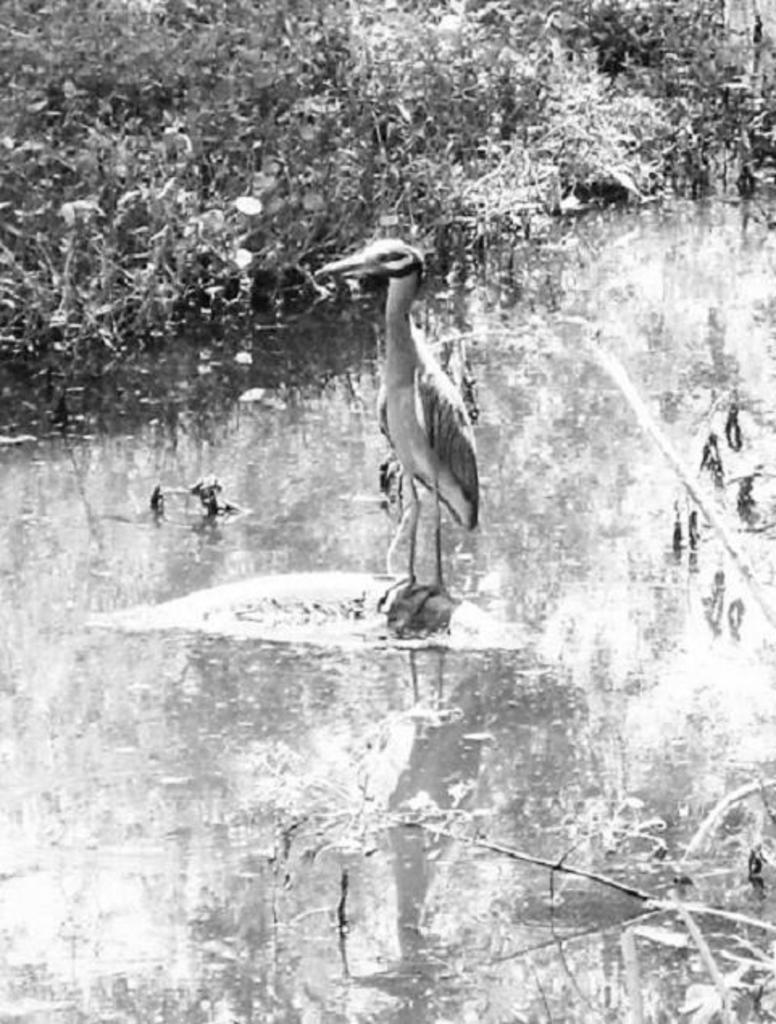What is the main subject in the middle of the image? There is a crane in the middle of the image. What can be seen in the image besides the crane? There is some water visible in the image. What type of vegetation is present in the background of the image? There are plants in the background of the image. What is the color scheme of the image? The image is black and white. What thought is the crane having in the image? There is no indication of the crane's thoughts in the image, as it is an inanimate object. 